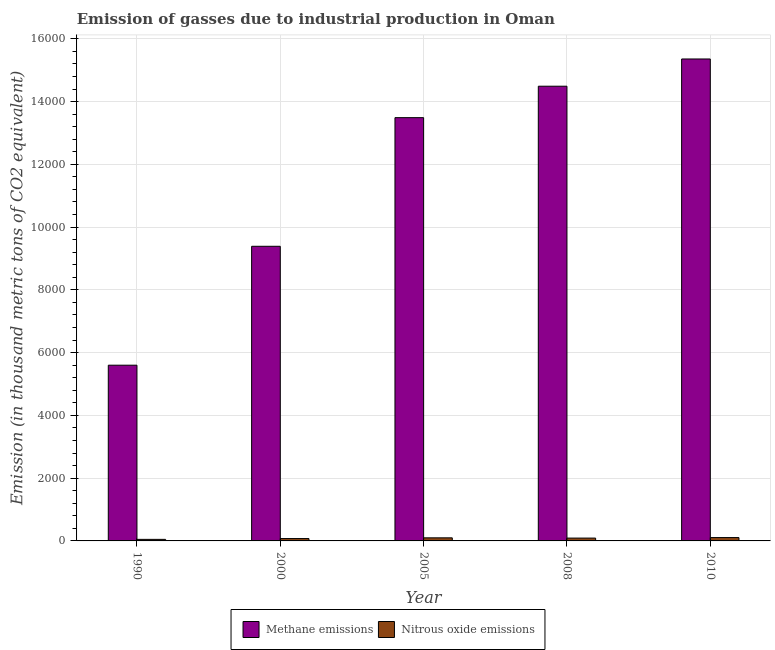How many different coloured bars are there?
Your response must be concise. 2. How many bars are there on the 2nd tick from the left?
Your answer should be very brief. 2. How many bars are there on the 1st tick from the right?
Give a very brief answer. 2. What is the label of the 4th group of bars from the left?
Provide a succinct answer. 2008. What is the amount of nitrous oxide emissions in 2010?
Provide a short and direct response. 106.9. Across all years, what is the maximum amount of methane emissions?
Offer a very short reply. 1.54e+04. Across all years, what is the minimum amount of nitrous oxide emissions?
Make the answer very short. 49.4. In which year was the amount of nitrous oxide emissions maximum?
Ensure brevity in your answer.  2010. What is the total amount of nitrous oxide emissions in the graph?
Give a very brief answer. 420.4. What is the difference between the amount of methane emissions in 1990 and that in 2000?
Your response must be concise. -3788.8. What is the difference between the amount of methane emissions in 1990 and the amount of nitrous oxide emissions in 2005?
Your answer should be very brief. -7887.8. What is the average amount of methane emissions per year?
Your response must be concise. 1.17e+04. What is the ratio of the amount of nitrous oxide emissions in 2000 to that in 2010?
Offer a terse response. 0.71. Is the difference between the amount of methane emissions in 2000 and 2008 greater than the difference between the amount of nitrous oxide emissions in 2000 and 2008?
Keep it short and to the point. No. What is the difference between the highest and the second highest amount of nitrous oxide emissions?
Offer a very short reply. 8.5. What is the difference between the highest and the lowest amount of methane emissions?
Keep it short and to the point. 9757.6. Is the sum of the amount of nitrous oxide emissions in 2005 and 2010 greater than the maximum amount of methane emissions across all years?
Keep it short and to the point. Yes. What does the 2nd bar from the left in 2005 represents?
Give a very brief answer. Nitrous oxide emissions. What does the 1st bar from the right in 2010 represents?
Give a very brief answer. Nitrous oxide emissions. How many bars are there?
Your answer should be compact. 10. Are all the bars in the graph horizontal?
Keep it short and to the point. No. How many years are there in the graph?
Provide a succinct answer. 5. What is the difference between two consecutive major ticks on the Y-axis?
Ensure brevity in your answer.  2000. Where does the legend appear in the graph?
Offer a very short reply. Bottom center. How many legend labels are there?
Provide a short and direct response. 2. What is the title of the graph?
Offer a very short reply. Emission of gasses due to industrial production in Oman. What is the label or title of the X-axis?
Your answer should be very brief. Year. What is the label or title of the Y-axis?
Make the answer very short. Emission (in thousand metric tons of CO2 equivalent). What is the Emission (in thousand metric tons of CO2 equivalent) of Methane emissions in 1990?
Give a very brief answer. 5599.6. What is the Emission (in thousand metric tons of CO2 equivalent) in Nitrous oxide emissions in 1990?
Offer a terse response. 49.4. What is the Emission (in thousand metric tons of CO2 equivalent) of Methane emissions in 2000?
Provide a short and direct response. 9388.4. What is the Emission (in thousand metric tons of CO2 equivalent) in Nitrous oxide emissions in 2000?
Your response must be concise. 75.4. What is the Emission (in thousand metric tons of CO2 equivalent) in Methane emissions in 2005?
Offer a very short reply. 1.35e+04. What is the Emission (in thousand metric tons of CO2 equivalent) of Nitrous oxide emissions in 2005?
Your answer should be very brief. 98.4. What is the Emission (in thousand metric tons of CO2 equivalent) in Methane emissions in 2008?
Offer a very short reply. 1.45e+04. What is the Emission (in thousand metric tons of CO2 equivalent) in Nitrous oxide emissions in 2008?
Offer a very short reply. 90.3. What is the Emission (in thousand metric tons of CO2 equivalent) in Methane emissions in 2010?
Provide a succinct answer. 1.54e+04. What is the Emission (in thousand metric tons of CO2 equivalent) of Nitrous oxide emissions in 2010?
Offer a very short reply. 106.9. Across all years, what is the maximum Emission (in thousand metric tons of CO2 equivalent) in Methane emissions?
Offer a terse response. 1.54e+04. Across all years, what is the maximum Emission (in thousand metric tons of CO2 equivalent) in Nitrous oxide emissions?
Give a very brief answer. 106.9. Across all years, what is the minimum Emission (in thousand metric tons of CO2 equivalent) of Methane emissions?
Give a very brief answer. 5599.6. Across all years, what is the minimum Emission (in thousand metric tons of CO2 equivalent) of Nitrous oxide emissions?
Your response must be concise. 49.4. What is the total Emission (in thousand metric tons of CO2 equivalent) in Methane emissions in the graph?
Offer a very short reply. 5.83e+04. What is the total Emission (in thousand metric tons of CO2 equivalent) of Nitrous oxide emissions in the graph?
Keep it short and to the point. 420.4. What is the difference between the Emission (in thousand metric tons of CO2 equivalent) in Methane emissions in 1990 and that in 2000?
Your answer should be compact. -3788.8. What is the difference between the Emission (in thousand metric tons of CO2 equivalent) of Nitrous oxide emissions in 1990 and that in 2000?
Keep it short and to the point. -26. What is the difference between the Emission (in thousand metric tons of CO2 equivalent) in Methane emissions in 1990 and that in 2005?
Offer a very short reply. -7887.8. What is the difference between the Emission (in thousand metric tons of CO2 equivalent) in Nitrous oxide emissions in 1990 and that in 2005?
Offer a very short reply. -49. What is the difference between the Emission (in thousand metric tons of CO2 equivalent) of Methane emissions in 1990 and that in 2008?
Give a very brief answer. -8889.6. What is the difference between the Emission (in thousand metric tons of CO2 equivalent) in Nitrous oxide emissions in 1990 and that in 2008?
Offer a very short reply. -40.9. What is the difference between the Emission (in thousand metric tons of CO2 equivalent) of Methane emissions in 1990 and that in 2010?
Make the answer very short. -9757.6. What is the difference between the Emission (in thousand metric tons of CO2 equivalent) in Nitrous oxide emissions in 1990 and that in 2010?
Your answer should be compact. -57.5. What is the difference between the Emission (in thousand metric tons of CO2 equivalent) of Methane emissions in 2000 and that in 2005?
Offer a terse response. -4099. What is the difference between the Emission (in thousand metric tons of CO2 equivalent) in Methane emissions in 2000 and that in 2008?
Your answer should be compact. -5100.8. What is the difference between the Emission (in thousand metric tons of CO2 equivalent) in Nitrous oxide emissions in 2000 and that in 2008?
Your answer should be very brief. -14.9. What is the difference between the Emission (in thousand metric tons of CO2 equivalent) of Methane emissions in 2000 and that in 2010?
Your answer should be very brief. -5968.8. What is the difference between the Emission (in thousand metric tons of CO2 equivalent) of Nitrous oxide emissions in 2000 and that in 2010?
Provide a short and direct response. -31.5. What is the difference between the Emission (in thousand metric tons of CO2 equivalent) of Methane emissions in 2005 and that in 2008?
Your answer should be very brief. -1001.8. What is the difference between the Emission (in thousand metric tons of CO2 equivalent) in Nitrous oxide emissions in 2005 and that in 2008?
Your answer should be very brief. 8.1. What is the difference between the Emission (in thousand metric tons of CO2 equivalent) in Methane emissions in 2005 and that in 2010?
Provide a short and direct response. -1869.8. What is the difference between the Emission (in thousand metric tons of CO2 equivalent) of Methane emissions in 2008 and that in 2010?
Offer a very short reply. -868. What is the difference between the Emission (in thousand metric tons of CO2 equivalent) in Nitrous oxide emissions in 2008 and that in 2010?
Offer a very short reply. -16.6. What is the difference between the Emission (in thousand metric tons of CO2 equivalent) in Methane emissions in 1990 and the Emission (in thousand metric tons of CO2 equivalent) in Nitrous oxide emissions in 2000?
Provide a succinct answer. 5524.2. What is the difference between the Emission (in thousand metric tons of CO2 equivalent) of Methane emissions in 1990 and the Emission (in thousand metric tons of CO2 equivalent) of Nitrous oxide emissions in 2005?
Give a very brief answer. 5501.2. What is the difference between the Emission (in thousand metric tons of CO2 equivalent) in Methane emissions in 1990 and the Emission (in thousand metric tons of CO2 equivalent) in Nitrous oxide emissions in 2008?
Offer a terse response. 5509.3. What is the difference between the Emission (in thousand metric tons of CO2 equivalent) in Methane emissions in 1990 and the Emission (in thousand metric tons of CO2 equivalent) in Nitrous oxide emissions in 2010?
Keep it short and to the point. 5492.7. What is the difference between the Emission (in thousand metric tons of CO2 equivalent) of Methane emissions in 2000 and the Emission (in thousand metric tons of CO2 equivalent) of Nitrous oxide emissions in 2005?
Offer a very short reply. 9290. What is the difference between the Emission (in thousand metric tons of CO2 equivalent) in Methane emissions in 2000 and the Emission (in thousand metric tons of CO2 equivalent) in Nitrous oxide emissions in 2008?
Your answer should be compact. 9298.1. What is the difference between the Emission (in thousand metric tons of CO2 equivalent) of Methane emissions in 2000 and the Emission (in thousand metric tons of CO2 equivalent) of Nitrous oxide emissions in 2010?
Offer a very short reply. 9281.5. What is the difference between the Emission (in thousand metric tons of CO2 equivalent) of Methane emissions in 2005 and the Emission (in thousand metric tons of CO2 equivalent) of Nitrous oxide emissions in 2008?
Your response must be concise. 1.34e+04. What is the difference between the Emission (in thousand metric tons of CO2 equivalent) of Methane emissions in 2005 and the Emission (in thousand metric tons of CO2 equivalent) of Nitrous oxide emissions in 2010?
Your response must be concise. 1.34e+04. What is the difference between the Emission (in thousand metric tons of CO2 equivalent) of Methane emissions in 2008 and the Emission (in thousand metric tons of CO2 equivalent) of Nitrous oxide emissions in 2010?
Your answer should be very brief. 1.44e+04. What is the average Emission (in thousand metric tons of CO2 equivalent) of Methane emissions per year?
Your answer should be very brief. 1.17e+04. What is the average Emission (in thousand metric tons of CO2 equivalent) of Nitrous oxide emissions per year?
Your response must be concise. 84.08. In the year 1990, what is the difference between the Emission (in thousand metric tons of CO2 equivalent) of Methane emissions and Emission (in thousand metric tons of CO2 equivalent) of Nitrous oxide emissions?
Your answer should be compact. 5550.2. In the year 2000, what is the difference between the Emission (in thousand metric tons of CO2 equivalent) of Methane emissions and Emission (in thousand metric tons of CO2 equivalent) of Nitrous oxide emissions?
Provide a succinct answer. 9313. In the year 2005, what is the difference between the Emission (in thousand metric tons of CO2 equivalent) of Methane emissions and Emission (in thousand metric tons of CO2 equivalent) of Nitrous oxide emissions?
Provide a succinct answer. 1.34e+04. In the year 2008, what is the difference between the Emission (in thousand metric tons of CO2 equivalent) of Methane emissions and Emission (in thousand metric tons of CO2 equivalent) of Nitrous oxide emissions?
Your answer should be compact. 1.44e+04. In the year 2010, what is the difference between the Emission (in thousand metric tons of CO2 equivalent) in Methane emissions and Emission (in thousand metric tons of CO2 equivalent) in Nitrous oxide emissions?
Provide a succinct answer. 1.53e+04. What is the ratio of the Emission (in thousand metric tons of CO2 equivalent) of Methane emissions in 1990 to that in 2000?
Make the answer very short. 0.6. What is the ratio of the Emission (in thousand metric tons of CO2 equivalent) in Nitrous oxide emissions in 1990 to that in 2000?
Your answer should be compact. 0.66. What is the ratio of the Emission (in thousand metric tons of CO2 equivalent) of Methane emissions in 1990 to that in 2005?
Ensure brevity in your answer.  0.42. What is the ratio of the Emission (in thousand metric tons of CO2 equivalent) in Nitrous oxide emissions in 1990 to that in 2005?
Provide a succinct answer. 0.5. What is the ratio of the Emission (in thousand metric tons of CO2 equivalent) of Methane emissions in 1990 to that in 2008?
Provide a short and direct response. 0.39. What is the ratio of the Emission (in thousand metric tons of CO2 equivalent) of Nitrous oxide emissions in 1990 to that in 2008?
Offer a terse response. 0.55. What is the ratio of the Emission (in thousand metric tons of CO2 equivalent) of Methane emissions in 1990 to that in 2010?
Ensure brevity in your answer.  0.36. What is the ratio of the Emission (in thousand metric tons of CO2 equivalent) in Nitrous oxide emissions in 1990 to that in 2010?
Your answer should be compact. 0.46. What is the ratio of the Emission (in thousand metric tons of CO2 equivalent) in Methane emissions in 2000 to that in 2005?
Provide a succinct answer. 0.7. What is the ratio of the Emission (in thousand metric tons of CO2 equivalent) in Nitrous oxide emissions in 2000 to that in 2005?
Your answer should be compact. 0.77. What is the ratio of the Emission (in thousand metric tons of CO2 equivalent) in Methane emissions in 2000 to that in 2008?
Make the answer very short. 0.65. What is the ratio of the Emission (in thousand metric tons of CO2 equivalent) in Nitrous oxide emissions in 2000 to that in 2008?
Your answer should be compact. 0.83. What is the ratio of the Emission (in thousand metric tons of CO2 equivalent) of Methane emissions in 2000 to that in 2010?
Offer a very short reply. 0.61. What is the ratio of the Emission (in thousand metric tons of CO2 equivalent) of Nitrous oxide emissions in 2000 to that in 2010?
Your answer should be compact. 0.71. What is the ratio of the Emission (in thousand metric tons of CO2 equivalent) in Methane emissions in 2005 to that in 2008?
Keep it short and to the point. 0.93. What is the ratio of the Emission (in thousand metric tons of CO2 equivalent) in Nitrous oxide emissions in 2005 to that in 2008?
Keep it short and to the point. 1.09. What is the ratio of the Emission (in thousand metric tons of CO2 equivalent) of Methane emissions in 2005 to that in 2010?
Your response must be concise. 0.88. What is the ratio of the Emission (in thousand metric tons of CO2 equivalent) in Nitrous oxide emissions in 2005 to that in 2010?
Keep it short and to the point. 0.92. What is the ratio of the Emission (in thousand metric tons of CO2 equivalent) in Methane emissions in 2008 to that in 2010?
Ensure brevity in your answer.  0.94. What is the ratio of the Emission (in thousand metric tons of CO2 equivalent) of Nitrous oxide emissions in 2008 to that in 2010?
Provide a short and direct response. 0.84. What is the difference between the highest and the second highest Emission (in thousand metric tons of CO2 equivalent) of Methane emissions?
Offer a very short reply. 868. What is the difference between the highest and the second highest Emission (in thousand metric tons of CO2 equivalent) of Nitrous oxide emissions?
Your answer should be compact. 8.5. What is the difference between the highest and the lowest Emission (in thousand metric tons of CO2 equivalent) of Methane emissions?
Your answer should be very brief. 9757.6. What is the difference between the highest and the lowest Emission (in thousand metric tons of CO2 equivalent) of Nitrous oxide emissions?
Your answer should be very brief. 57.5. 